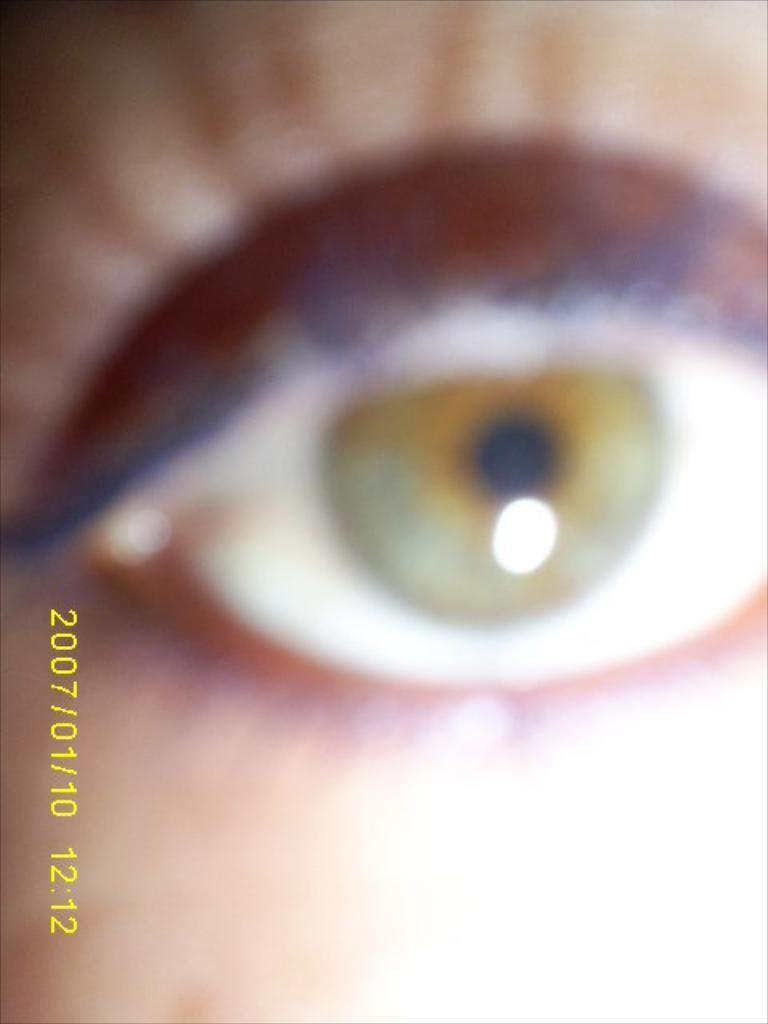What is the main subject of the image? The main subject of the image is a person's eye. Can you describe any additional features of the image? Yes, there is a watermark on the image. What type of punishment is being administered in the image? There is no punishment being administered in the image; it only features a person's eye and a watermark. What kind of sticks can be seen in the image? There are no sticks present in the image. 